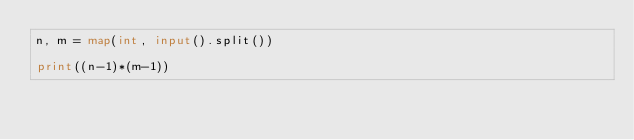<code> <loc_0><loc_0><loc_500><loc_500><_Python_>n, m = map(int, input().split())

print((n-1)*(m-1))
</code> 